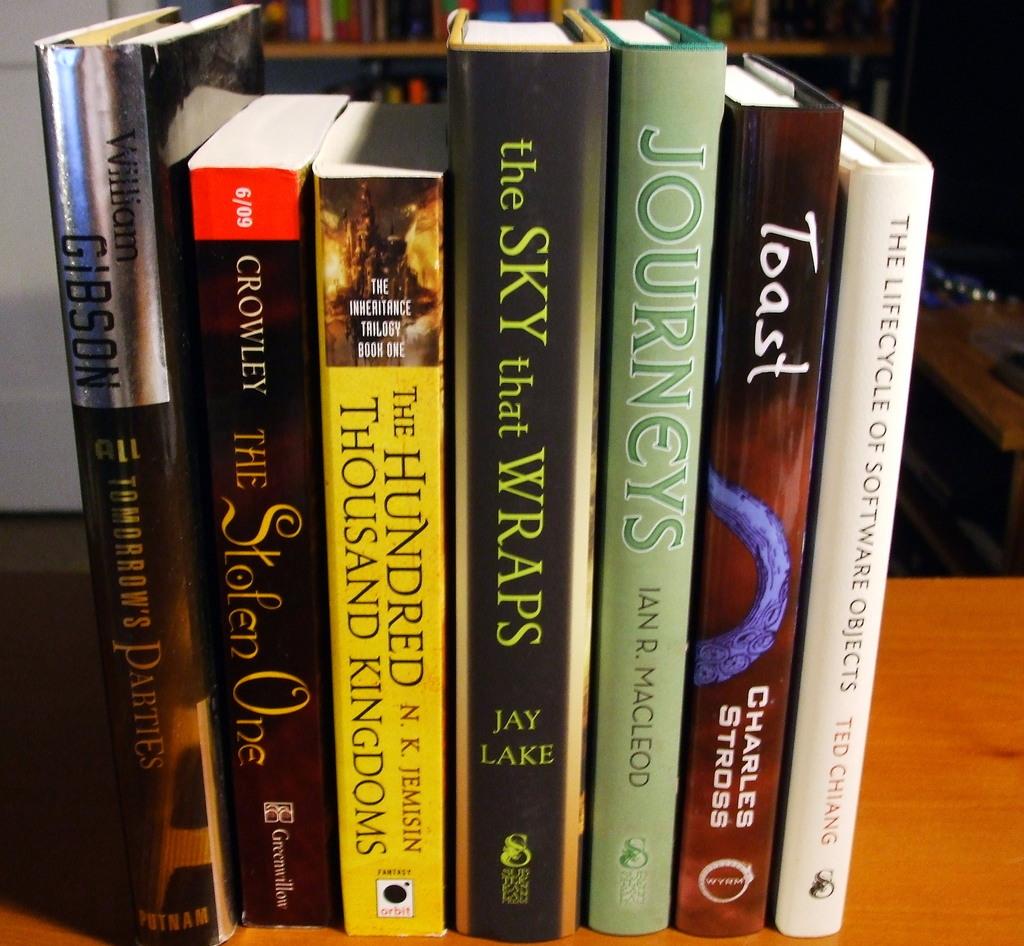What book shown here did jay lake write?
Your answer should be very brief. The sky that wraps. 